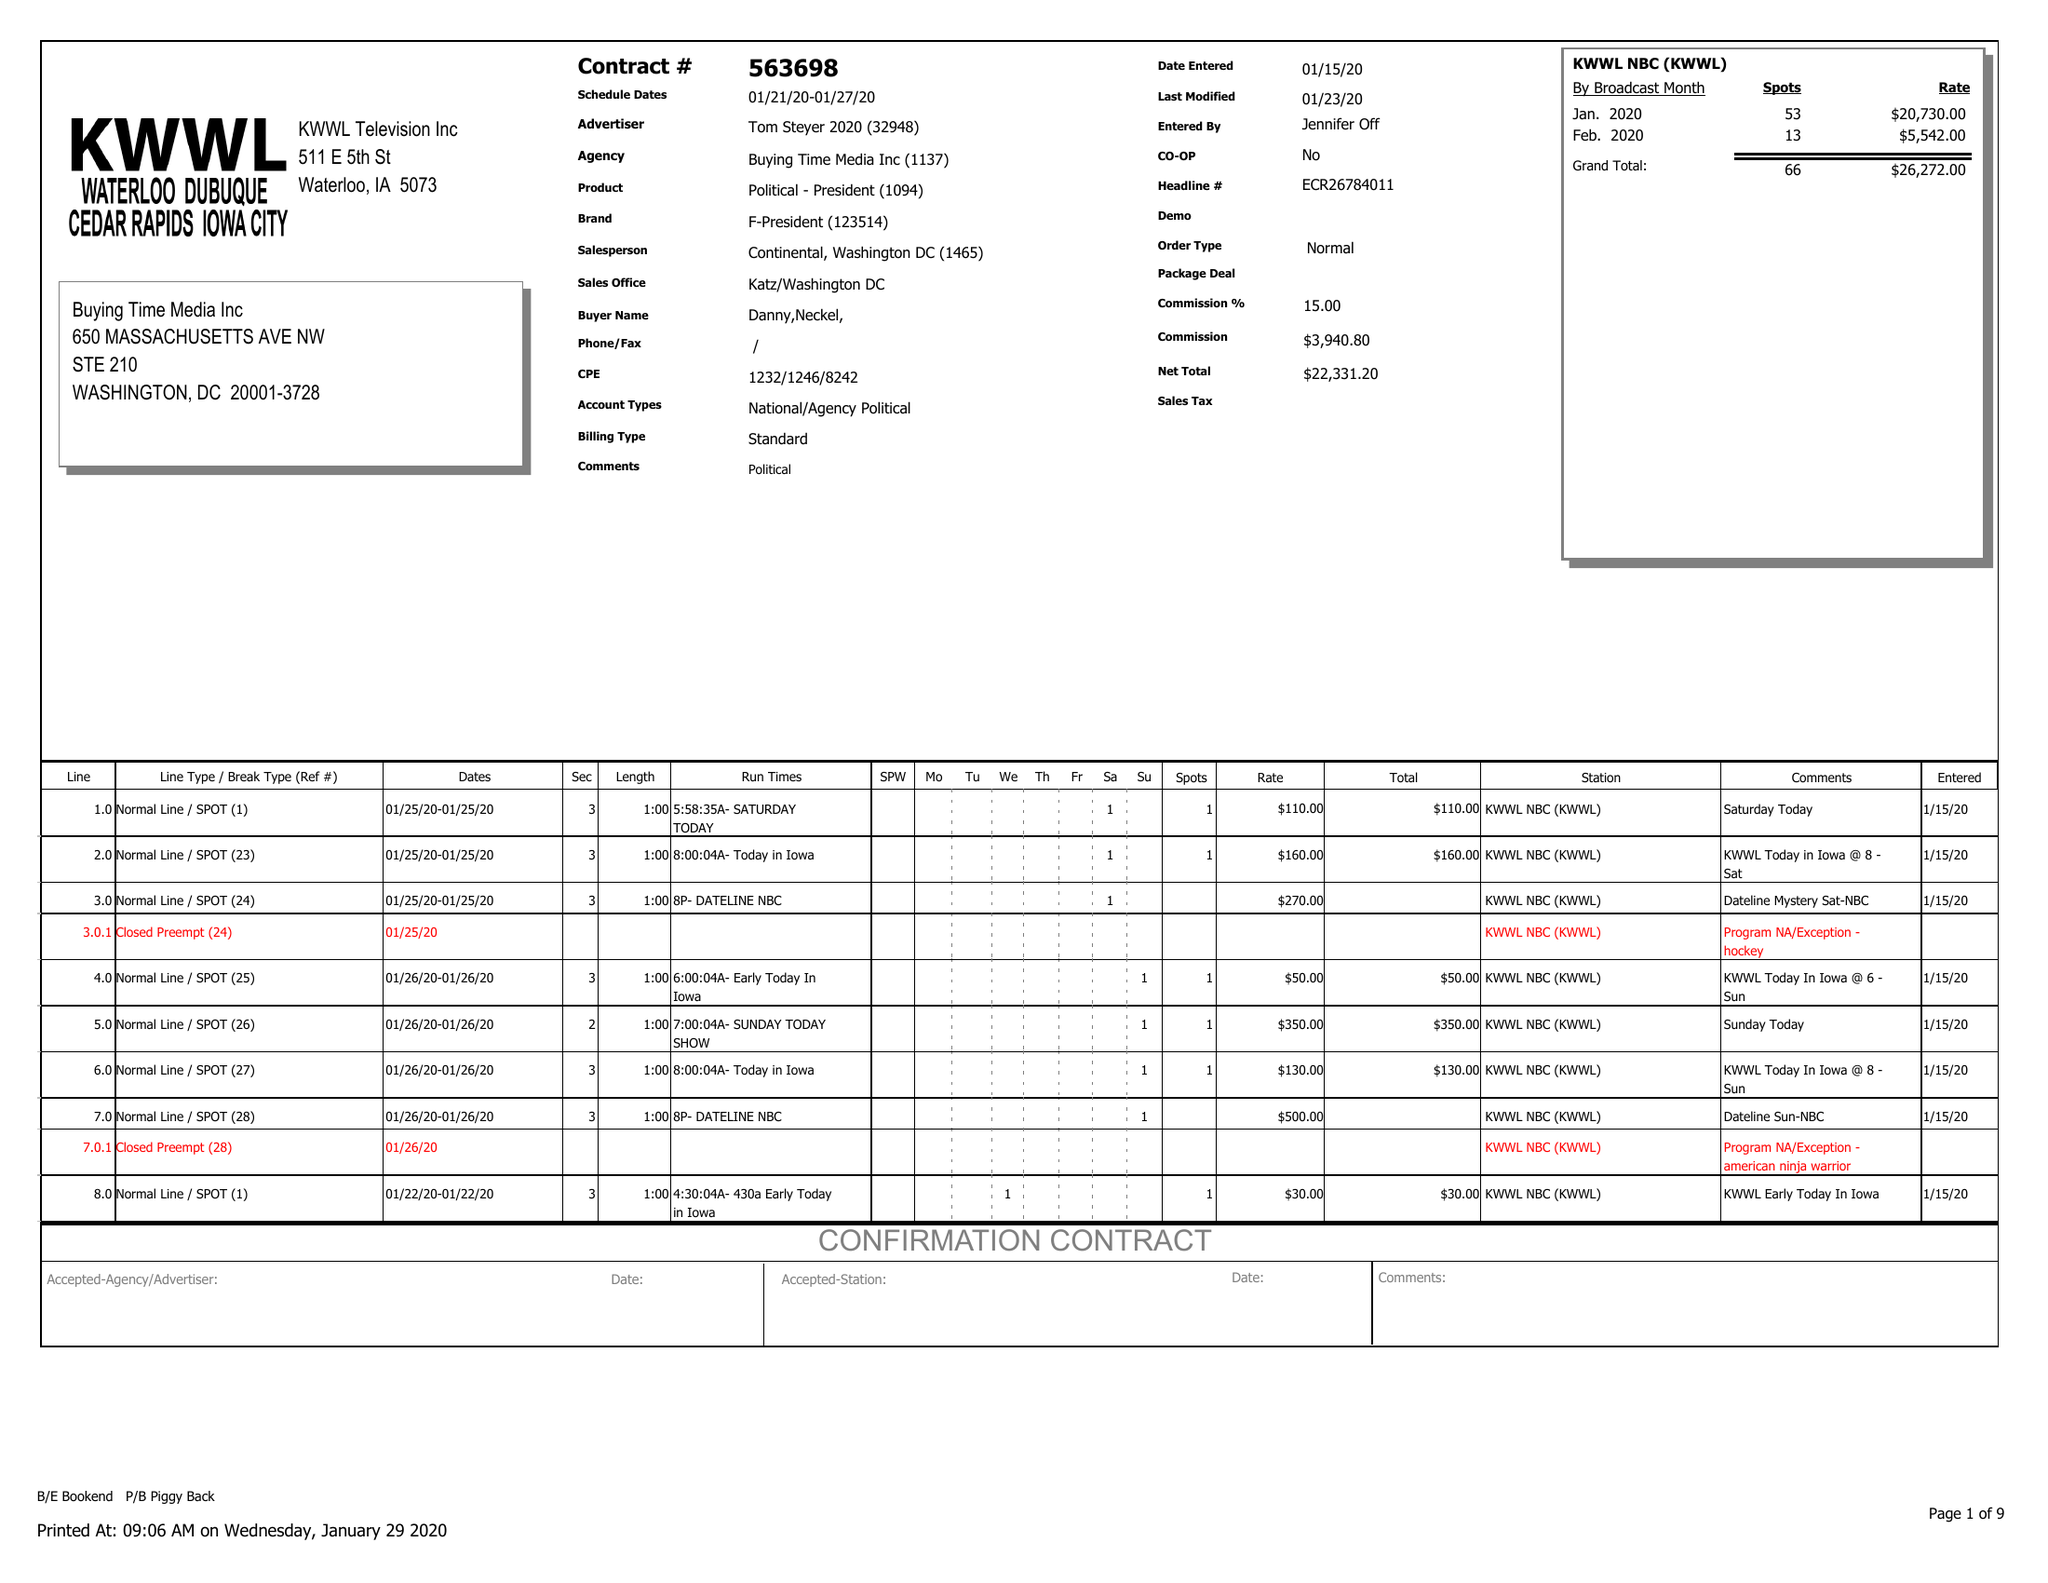What is the value for the contract_num?
Answer the question using a single word or phrase. 563698 